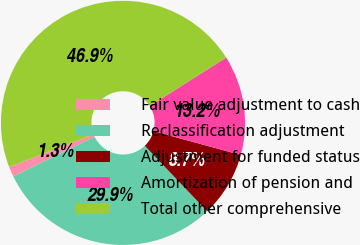Convert chart to OTSL. <chart><loc_0><loc_0><loc_500><loc_500><pie_chart><fcel>Fair value adjustment to cash<fcel>Reclassification adjustment<fcel>Adjustment for funded status<fcel>Amortization of pension and<fcel>Total other comprehensive<nl><fcel>1.34%<fcel>29.88%<fcel>8.66%<fcel>13.21%<fcel>46.9%<nl></chart> 